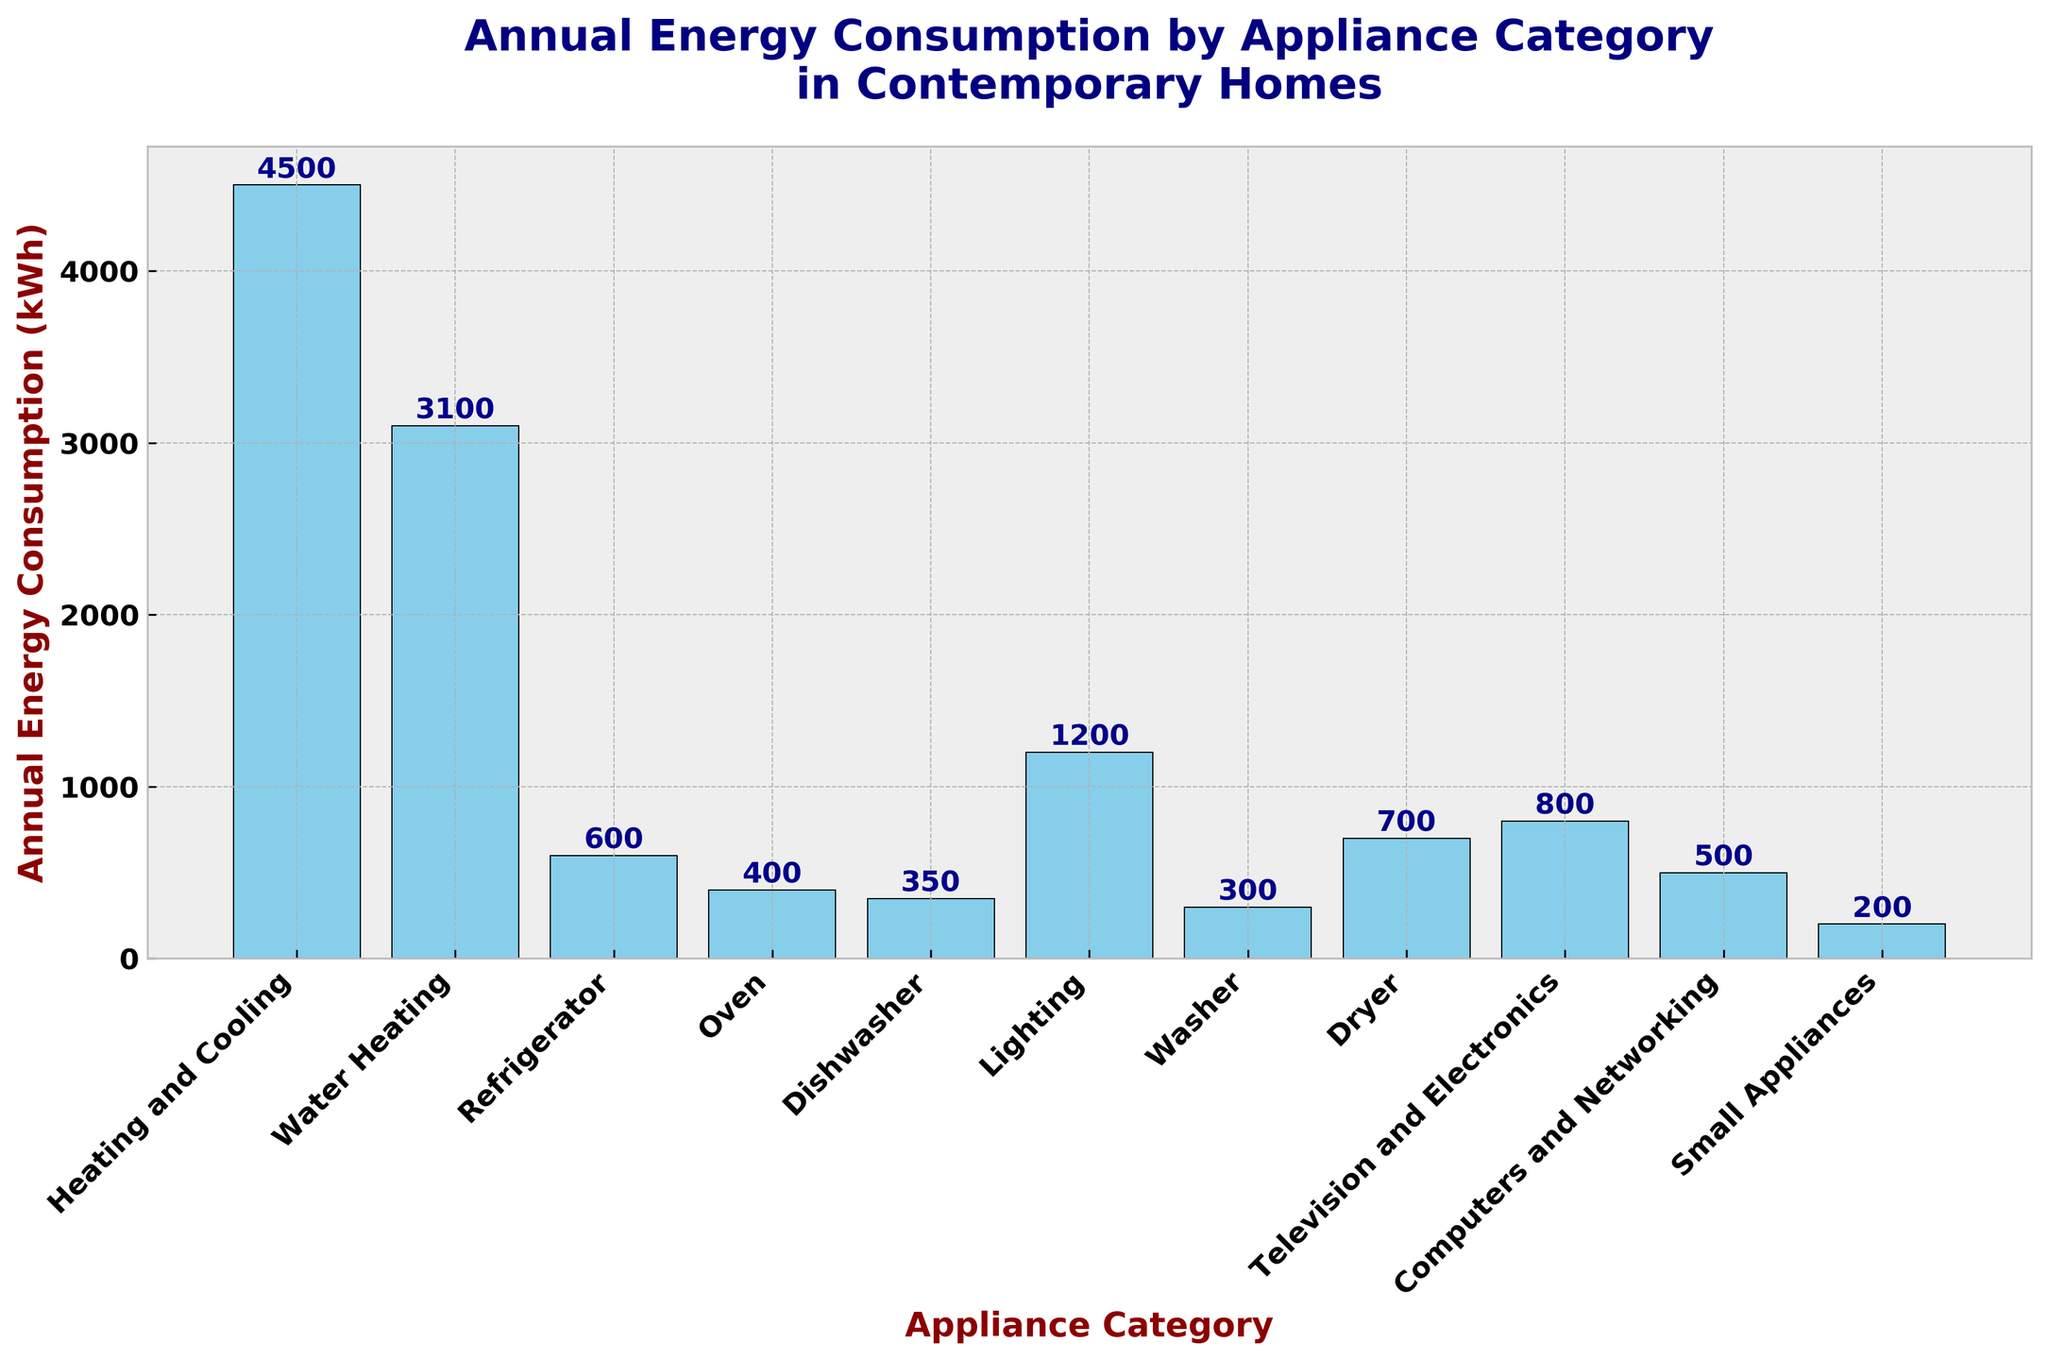Which appliance category consumes the most energy annually? Look at the height of the bars. The tallest bar represents "Heating and Cooling".
Answer: Heating and Cooling Which two categories have an annual energy consumption différence of 100 kWh? Compare the heights of the bars. The bars for Washer (300 kWh) and Small Appliances (200 kWh) have a difference of 100 kWh.
Answer: Washer and Small Appliances What is the total annual energy consumption for the categories Refrigerator, Oven, and Dishwasher combined? Add the values for Refrigerator (600 kWh), Oven (400 kWh), and Dishwasher (350 kWh). The total is 600 + 400 + 350 = 1350 kWh.
Answer: 1350 kWh Which categories have an annual energy consumption greater than 1000 kWh? Identify the bars higher than the 1000 kWh mark. "Heating and Cooling", "Water Heating", and "Lighting" consume more than 1000 kWh.
Answer: Heating and Cooling, Water Heating, and Lighting What is the difference in energy consumption between Television and Electronics and Computers and Networking? Subtract the energy consumption of Computers and Networking (500 kWh) from Television and Electronics (800 kWh). The difference is 800 - 500 = 300 kWh.
Answer: 300 kWh How many appliance categories consume less than 1000 kWh annually? Count the bars that are below the 1000 kWh mark. There are eight categories: Refrigerator, Oven, Dishwasher, Washer, Dryer, Television and Electronics, Computers and Networking, and Small Appliances.
Answer: 8 Which category has an energy consumption almost equal to the total combined energy consumption of the Oven and Television and Electronics? Add the Oven (400 kWh) and Television and Electronics (800 kWh) to get 400 + 800 = 1200 kWh. Compare this to the categories. "Lighting" is almost equal with 1200 kWh.
Answer: Lighting What percentage of the total energy consumption is used by Heating and Cooling? First, sum all the energy consumption values: 4500 + 3100 + 600 + 400 + 350 + 1200 + 300 + 700 + 800 + 500 + 200 = 11650 kWh. Then, divide Heating and Cooling (4500 kWh) by the total and multiply by 100 to get the percentage: (4500 / 11650) * 100 ≈ 38.6%.
Answer: 38.6% Which appliance category is the third most energy-consuming? Rank the categories by bar height. The third tallest bar after Heating and Cooling and Water Heating is Lighting.
Answer: Lighting 